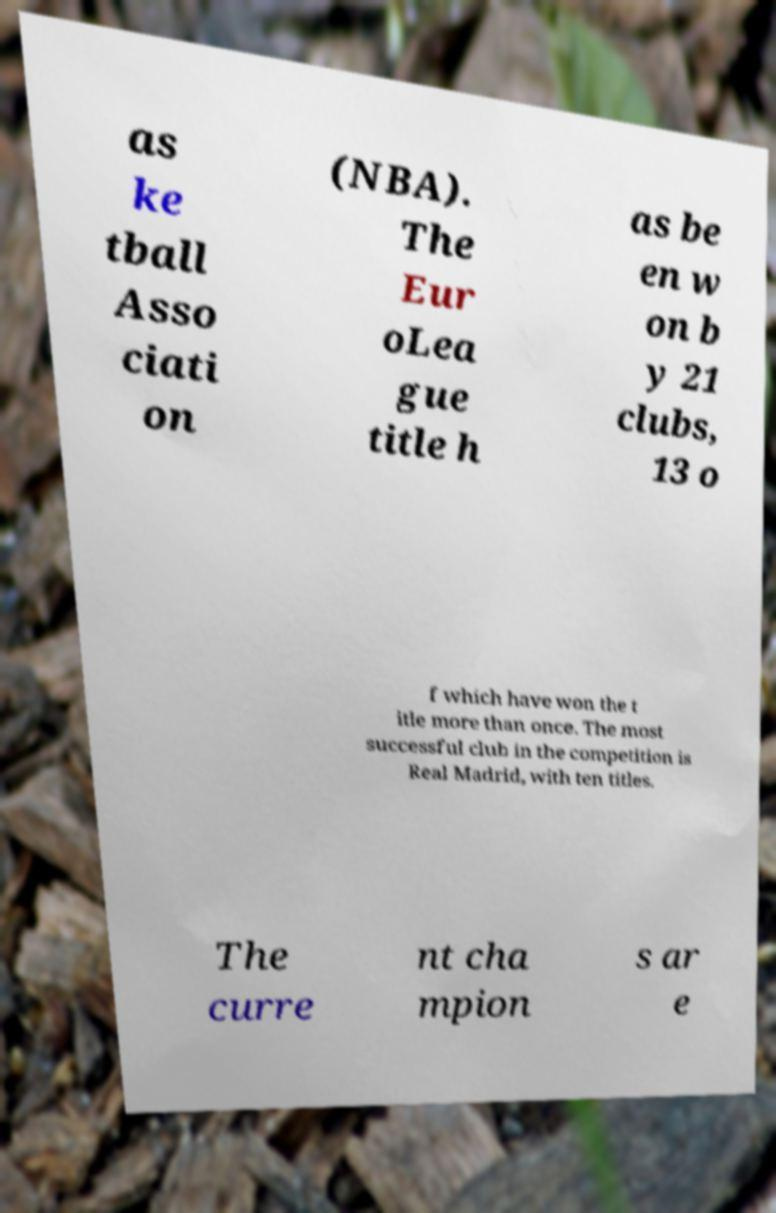For documentation purposes, I need the text within this image transcribed. Could you provide that? as ke tball Asso ciati on (NBA). The Eur oLea gue title h as be en w on b y 21 clubs, 13 o f which have won the t itle more than once. The most successful club in the competition is Real Madrid, with ten titles. The curre nt cha mpion s ar e 